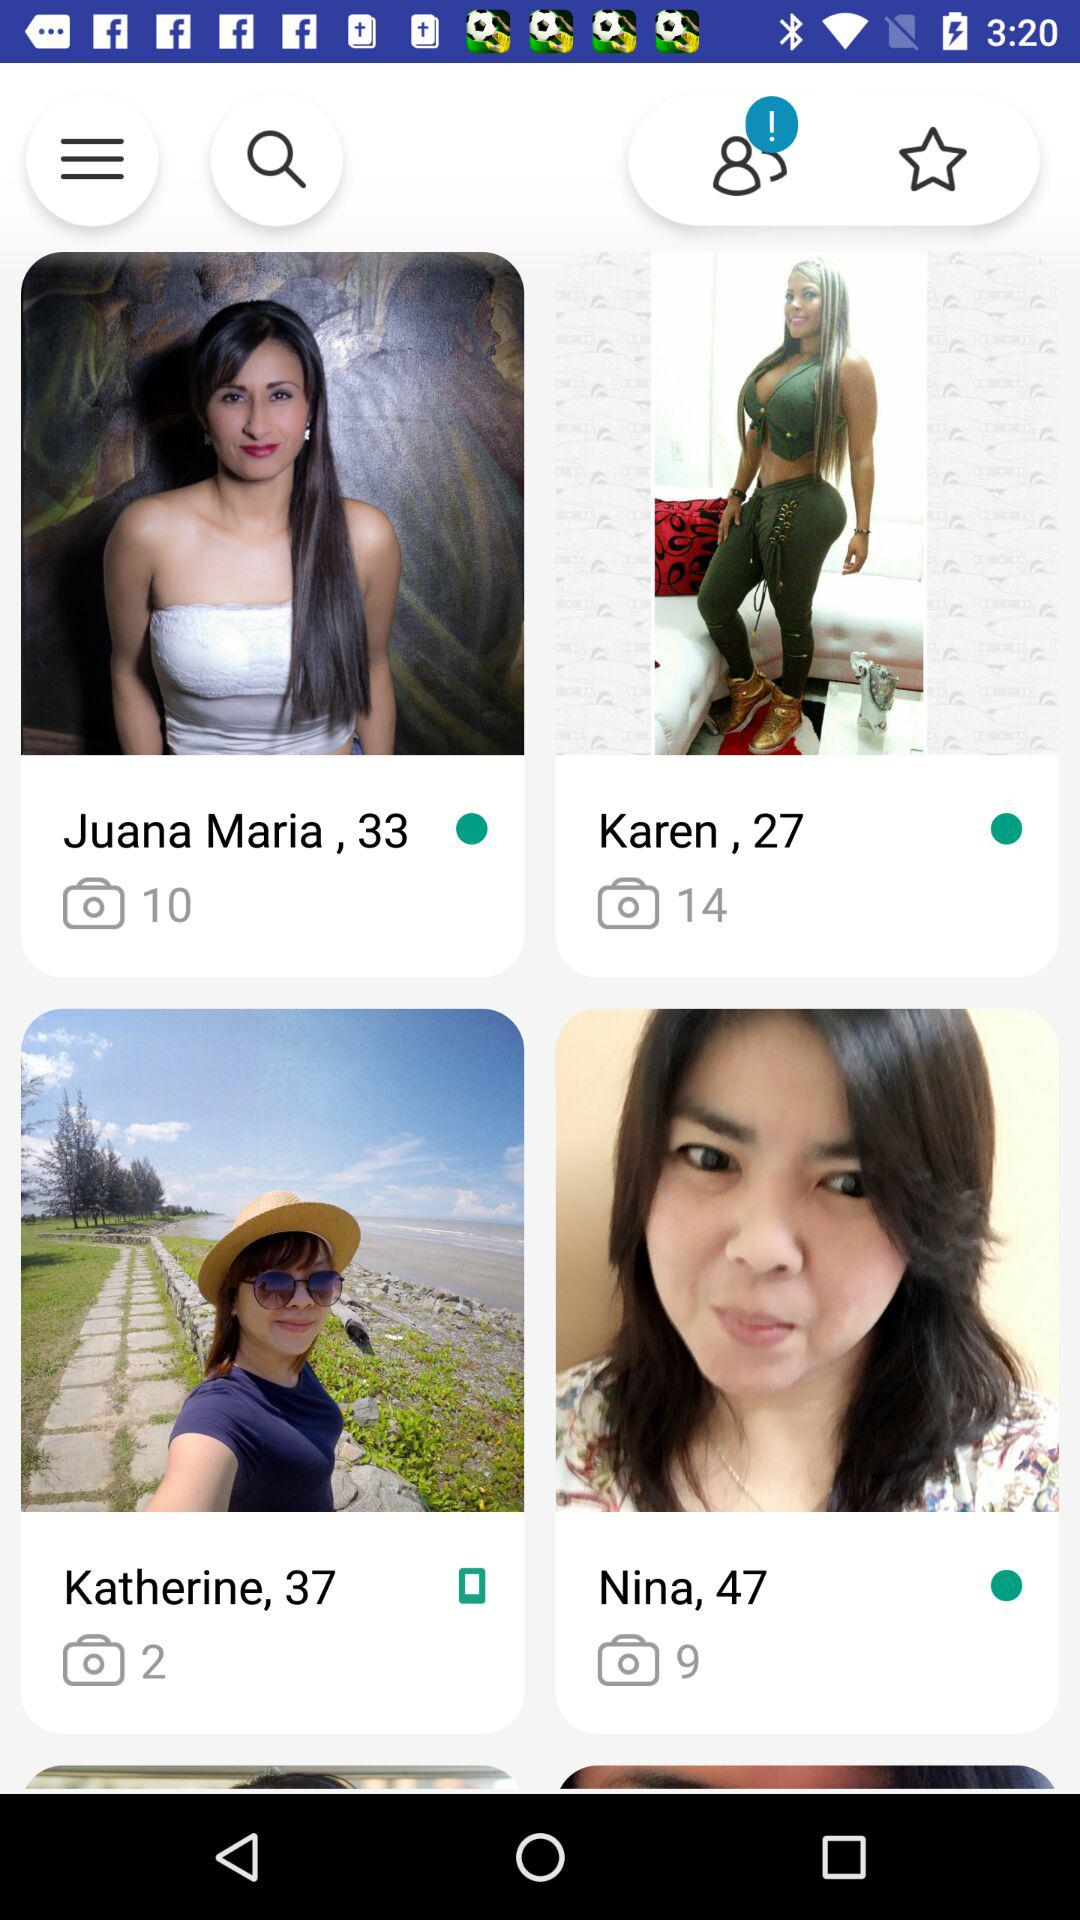How many more photos did Karen take than Juana Maria?
Answer the question using a single word or phrase. 4 